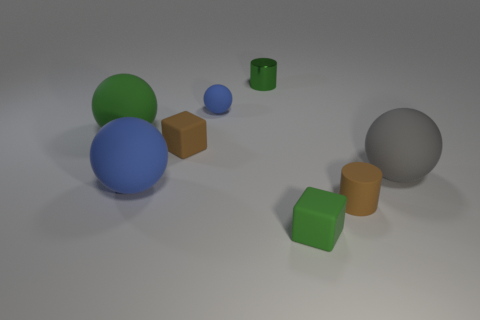Add 2 tiny brown objects. How many objects exist? 10 Subtract all blocks. How many objects are left? 6 Add 6 small green cylinders. How many small green cylinders exist? 7 Subtract 0 yellow cylinders. How many objects are left? 8 Subtract all big purple matte cylinders. Subtract all large gray rubber balls. How many objects are left? 7 Add 8 cylinders. How many cylinders are left? 10 